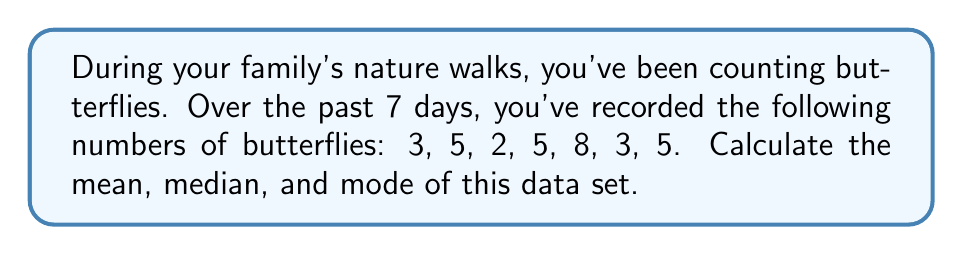Help me with this question. Let's calculate the mean, median, and mode step-by-step:

1. Mean:
   The mean is the average of all numbers in the data set.
   $$\text{Mean} = \frac{\text{Sum of all values}}{\text{Number of values}}$$
   $$\text{Mean} = \frac{3 + 5 + 2 + 5 + 8 + 3 + 5}{7} = \frac{31}{7} \approx 4.43$$

2. Median:
   To find the median, first order the numbers from least to greatest:
   2, 3, 3, 5, 5, 5, 8
   With 7 numbers, the median is the middle (4th) number.
   $$\text{Median} = 5$$

3. Mode:
   The mode is the value that appears most frequently in the data set.
   $$\text{Mode} = 5$$ (appears three times)
Answer: Mean: $\frac{31}{7} \approx 4.43$, Median: 5, Mode: 5 